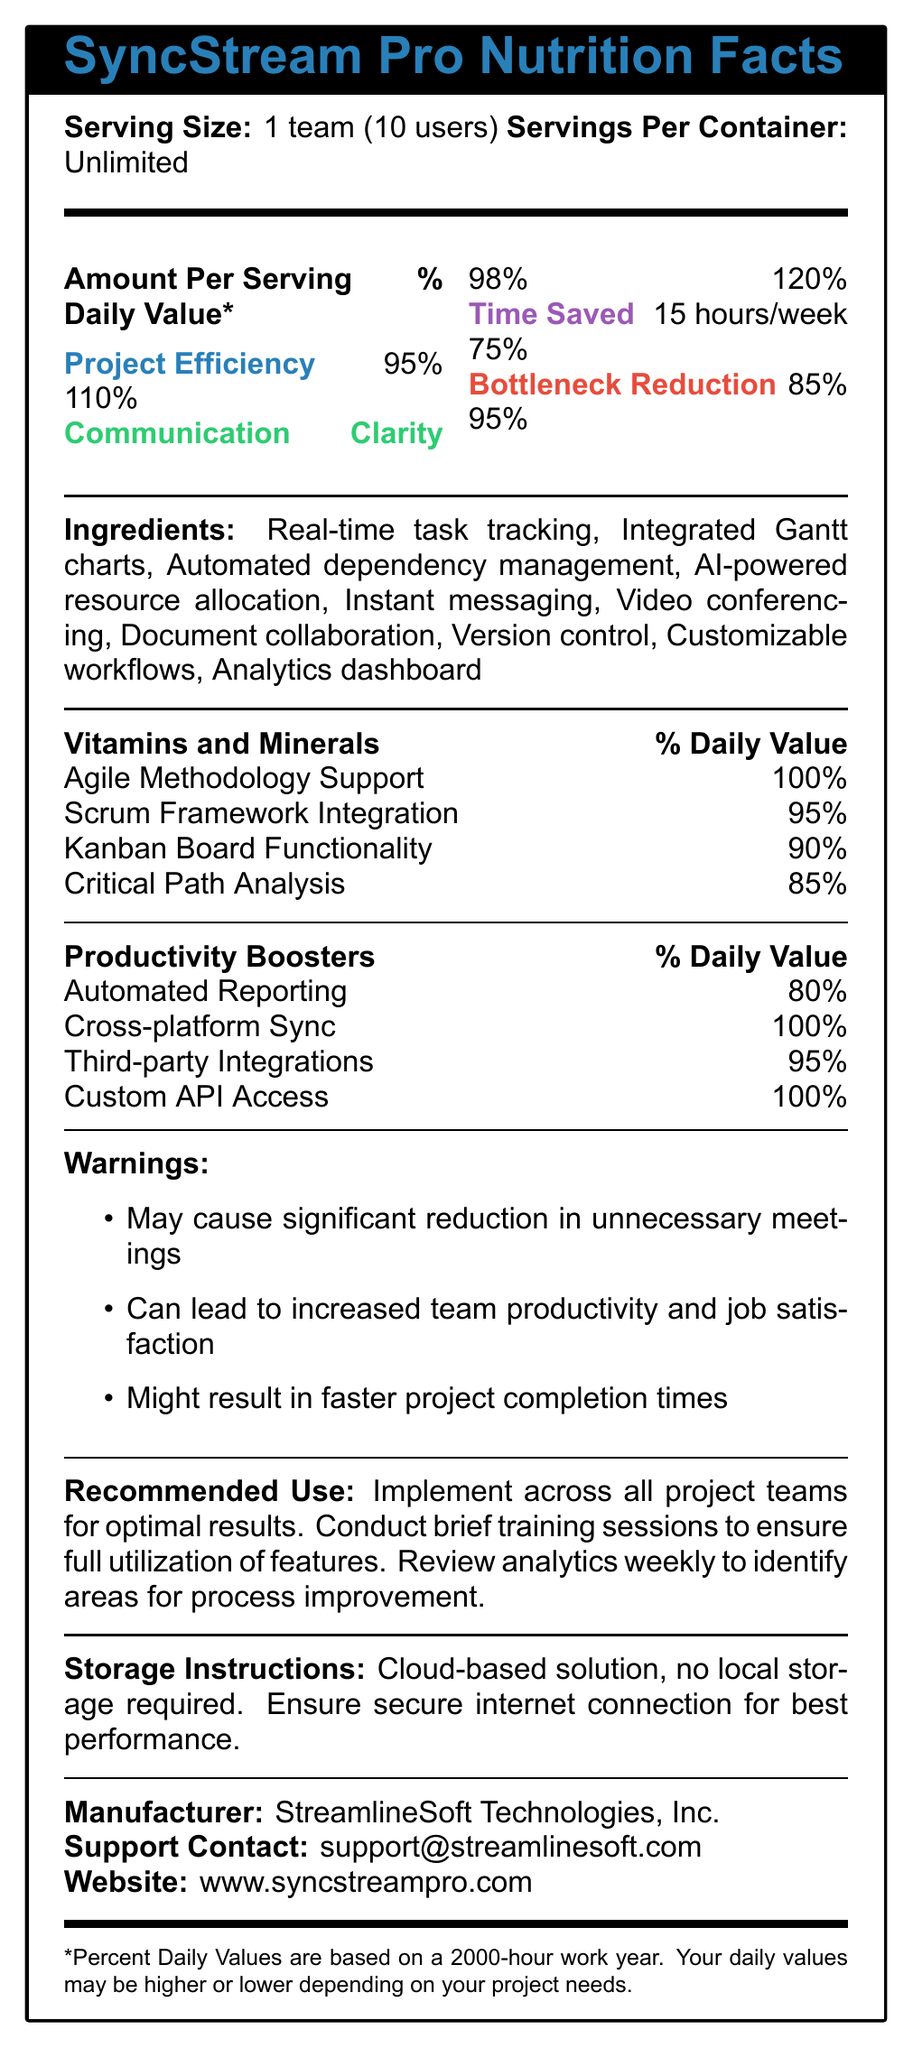what is the serving size of SyncStream Pro? The serving size is clearly indicated at the top of the document.
Answer: 1 team (10 users) how many hours per week can be saved with SyncStream Pro? The "Time Saved" section specifies a value of 15 hours per week.
Answer: 15 hours/week what is the name of the manufacturer of SyncStream Pro? The manufacturer is listed towards the bottom of the document.
Answer: StreamlineSoft Technologies, Inc. list three ingredients in SyncStream Pro. These are part of the "Ingredients" list in the document.
Answer: Real-time task tracking, Integrated Gantt charts, AI-powered resource allocation what is the support contact email for SyncStream Pro? The support contact is listed at the bottom of the document.
Answer: support@streamlinesoft.com which item has the highest percentage in the vitamins and minerals section? A. Agile Methodology Support B. Scrum Framework Integration C. Kanban Board Functionality Agile Methodology Support is 100%, which is the highest in that section.
Answer: A which of the following is a Productivity Booster? 1. Real-time task tracking 2. Cross-platform Sync 3. Agile Methodology Support Cross-platform Sync is listed under the "Productivity Boosters" section.
Answer: 2 can SyncStream Pro lead to increased team productivity? It is mentioned under the "Warnings" section that it can lead to increased team productivity.
Answer: Yes what is the main purpose of SyncStream Pro? The document lists various features and metrics indicating the main purpose is to improve project efficiency and clarity, save time, and reduce bottlenecks.
Answer: To streamline communication and reduce bottlenecks in project management does SyncStream Pro support Agile Methodology? Agile Methodology Support is listed under the "Vitamins and Minerals" section with a value of 100%.
Answer: Yes how many users does one serving of SyncStream Pro support? The serving size is defined as "1 team (10 users)".
Answer: 10 users what percentage of Communication Clarity does SyncStream Pro provide? The percentage is listed under "Communication Clarity" in the Amount Per Serving section.
Answer: 98% what are the daily values of Project Efficiency and Communication Clarity? The daily values are provided in the corresponding lines in the Amount Per Serving section.
Answer: 110% for Project Efficiency, 120% for Communication Clarity what are two features that reduce bottlenecks in project management? These features, listed among the Ingredients, are designed to manage and optimize resources and tasks, reducing project bottlenecks.
Answer: Automated dependency management, AI-powered resource allocation where can you find more information about SyncStream Pro online? The website URL is listed at the bottom of the document.
Answer: www.syncstreampro.com how should you store SyncStream Pro? The storage instructions indicate that it is a cloud-based solution and does not require local storage but does require a secure internet connection.
Answer: Ensure a secure internet connection for best performance. what is the serving amount for the container of SyncStream Pro? The document specifies that there are unlimited servings per container.
Answer: Unlimited is the document written in latex? The document itself does not specify the format in which it was written.
Answer: Not enough information 